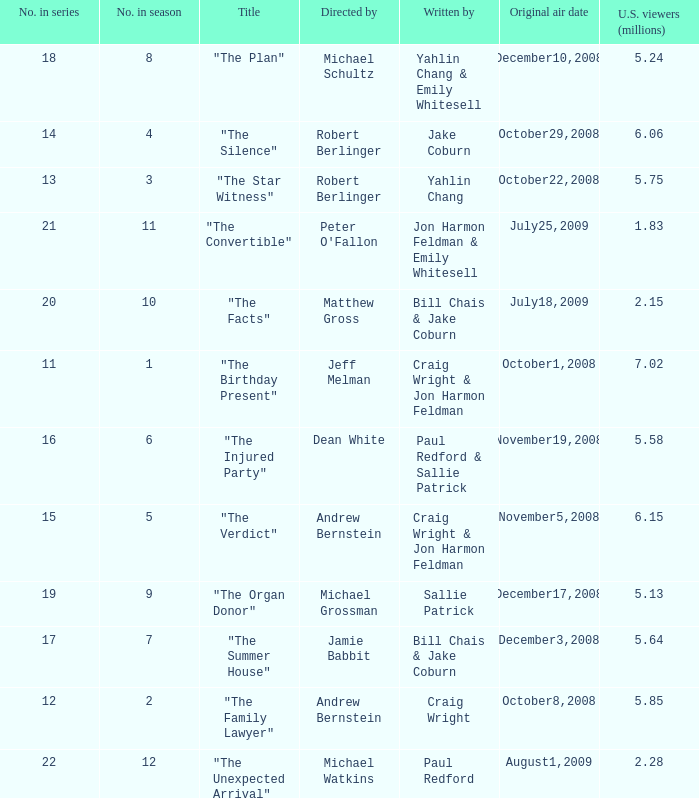What is the premiere air date of the episode directed by jeff melman? October1,2008. 